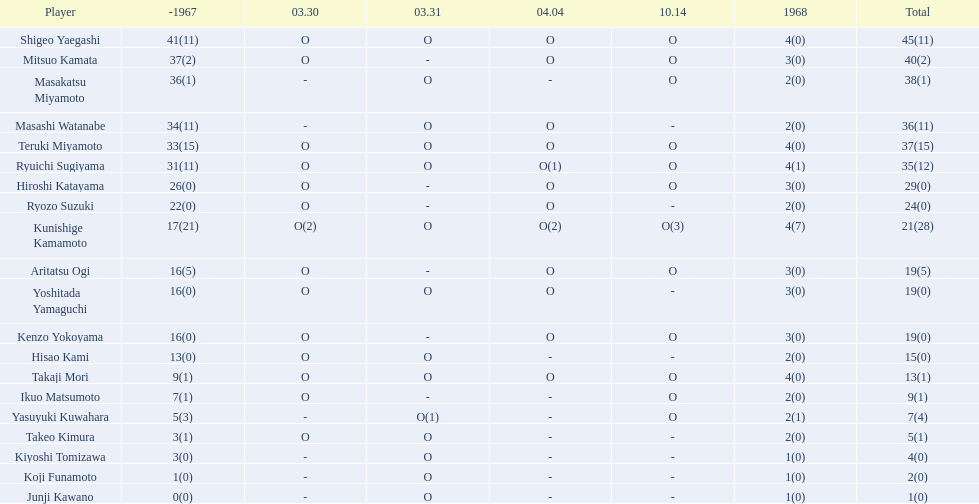What was the score of takaji mori? 13(1). And what was junji kawano's score? 1(0). Who possesses the greater number among them? Takaji Mori. 